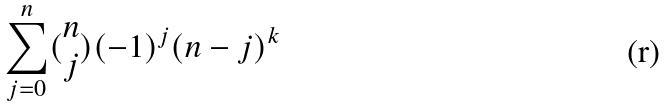Convert formula to latex. <formula><loc_0><loc_0><loc_500><loc_500>\sum _ { j = 0 } ^ { n } ( \begin{matrix} n \\ j \end{matrix} ) ( - 1 ) ^ { j } ( n - j ) ^ { k }</formula> 